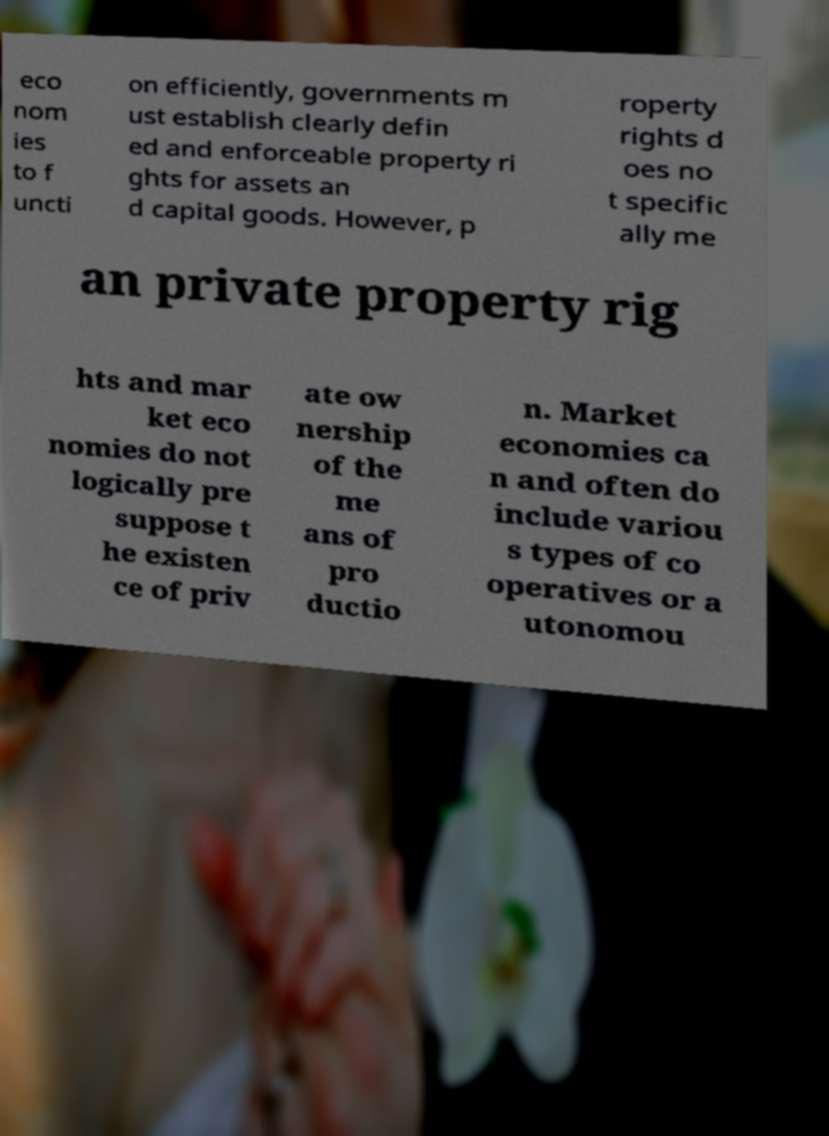Could you assist in decoding the text presented in this image and type it out clearly? eco nom ies to f uncti on efficiently, governments m ust establish clearly defin ed and enforceable property ri ghts for assets an d capital goods. However, p roperty rights d oes no t specific ally me an private property rig hts and mar ket eco nomies do not logically pre suppose t he existen ce of priv ate ow nership of the me ans of pro ductio n. Market economies ca n and often do include variou s types of co operatives or a utonomou 